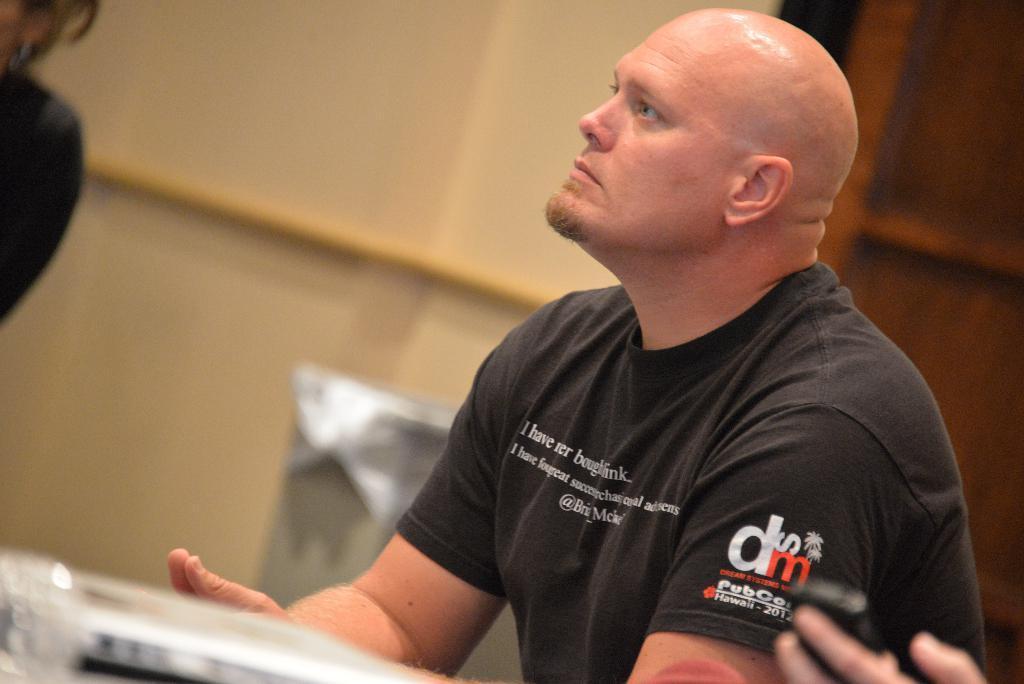Describe this image in one or two sentences. In the picture we can see a man sitting near the desk, he is wearing a black T-shirt and with some wordings on it and in the background, we can see a wall with a door which is brown in color. 